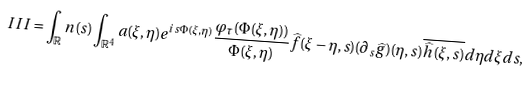Convert formula to latex. <formula><loc_0><loc_0><loc_500><loc_500>I I I = \int _ { \mathbb { R } } n ( s ) \int _ { \mathbb { R } ^ { 4 } } a ( \xi , \eta ) e ^ { i s \Phi ( \xi , \eta ) } \frac { \varphi _ { \tau } ( \Phi ( \xi , \eta ) ) } { \Phi ( \xi , \eta ) } \widehat { f } ( \xi - \eta , s ) ( \partial _ { s } \widehat { g } ) ( \eta , s ) \overline { \widehat { h } ( \xi , s ) } d \eta d \xi d s ,</formula> 